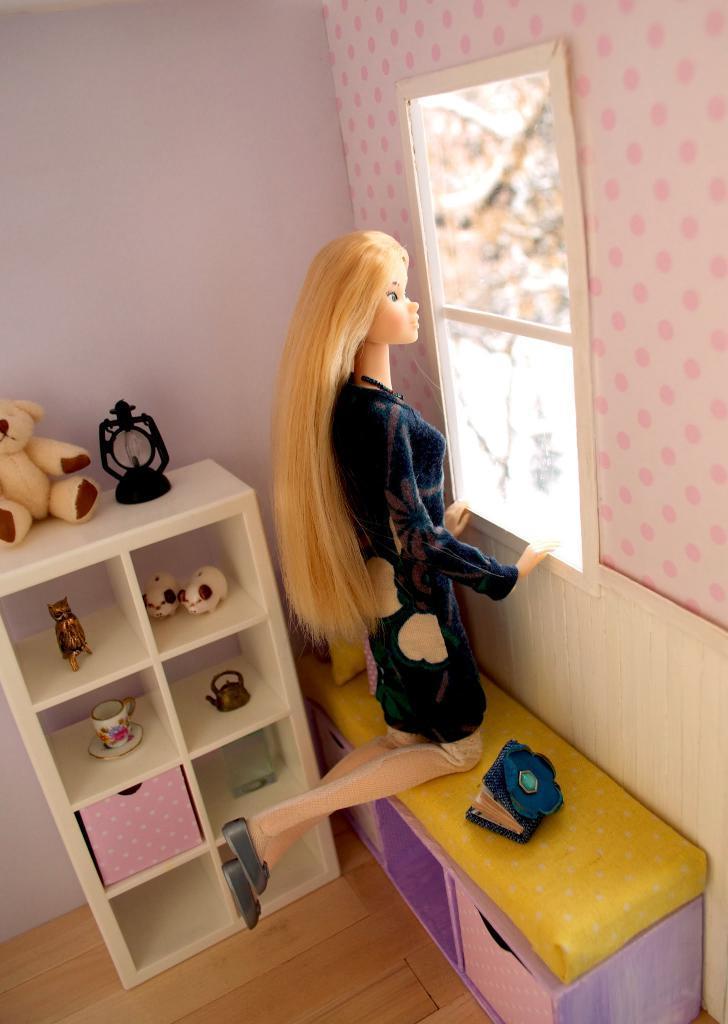Please provide a concise description of this image. This picture is inside view of a room. We can see table, toys, book, bench, watch, cup, wall, window, floor are present. 